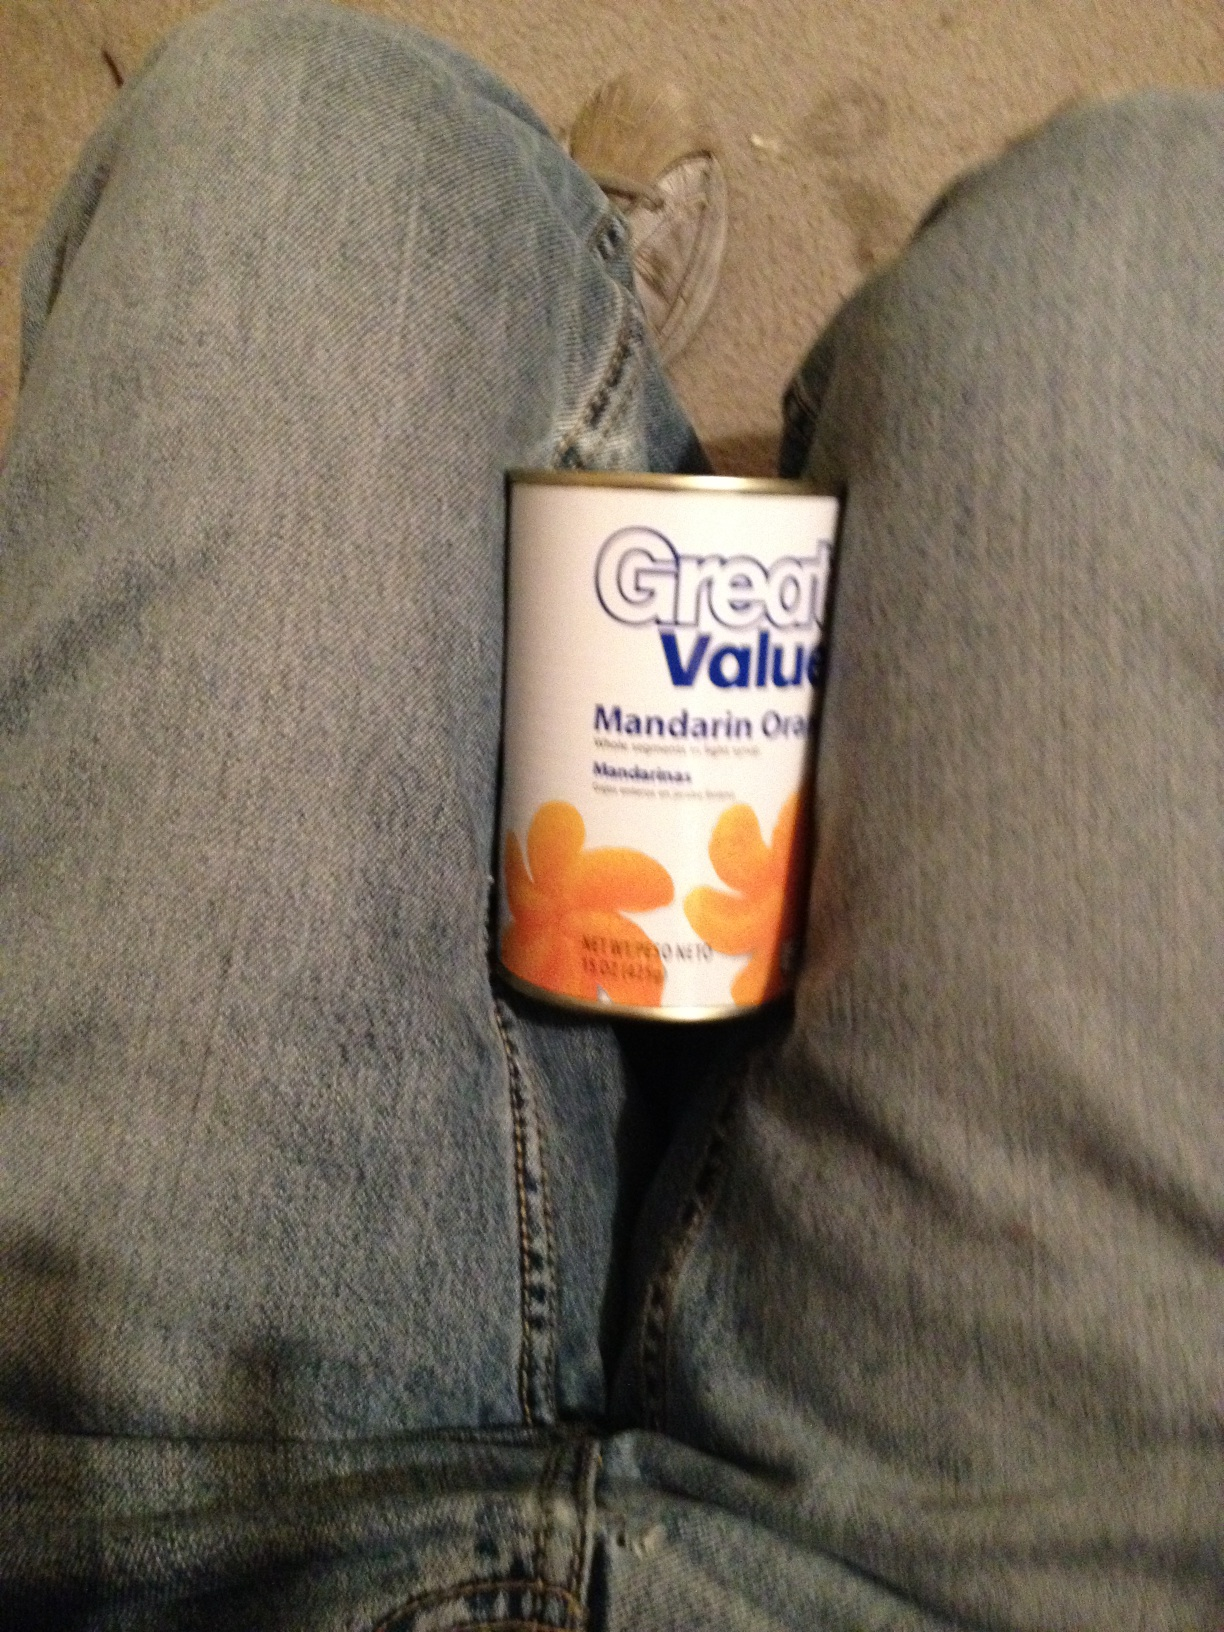What is the nutritional value of the content? Canned mandarin oranges are generally low in calories and fat. A typical serving size of about 1/2 cup (128g) usually contains around 50-70 calories, 0 grams of fat, 13-17 grams of carbohydrates (of which around 10-15 grams are sugars), and 1 gram of dietary fiber. They are also a good source of Vitamin C, providing around 20-50% of the daily requirement. Can you elaborate on how the vitamins in mandarin oranges benefit health? Certainly! Mandarin oranges are rich in Vitamin C, which is crucial for maintaining a healthy immune system. Vitamin C helps stimulate the production of white blood cells, which play a key role in fighting infections. It also acts as a powerful antioxidant, protecting cells from damage by free radicals. Additionally, Vitamin C is important for the synthesis of collagen, which aids in wound healing and maintains skin, cartilage, and bone health. Beyond Vitamin C, mandarin oranges also contain some Vitamin A, essential for good vision, and small amounts of B vitamins like B1 (thiamine) and B6, which are important for energy metabolism and brain health. Let’s dream up a fantastical use for these mandarin oranges. Imagine these mandarin oranges being the main ingredient in a magical elixir known as the 'Sunshine Elixir'! According to ancient legends, consuming this elixir grants the drinker temporary powers of joy and vitality, making them feel as if they are basking in the warmth of the midday sun. Crafted by mythical forest creatures in a hidden grove, this golden liquid can also summon a gentle golden glow around the drinker, warding off negative energy and bringing a burst of creativity and positivity to anyone who drinks it. It's said that the recipe includes not just mandarin oranges for sweetness but also rare herbs and a touch of stardust collected from falling meteors. Describe another realistic usage scenario of this can similar to the first one. You're hosting a potluck brunch with friends, and you decide to bring a refreshing and easy fruit cocktail to share. You combine the mandarin oranges with chunks of pineapple, grapes, and cherries, creating a colorful and tasty dish. When you arrive at the brunch, everyone appreciates the light and fruity addition to the meal, and the mandarin oranges add a sweet, zesty note that complements the other fruits perfectly. 